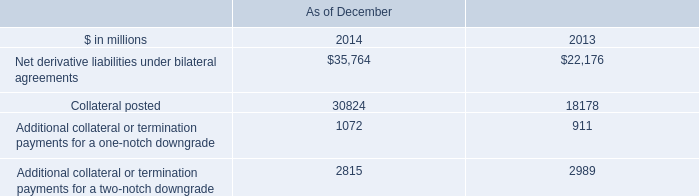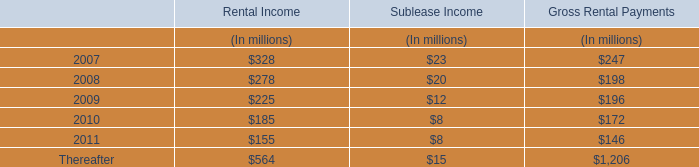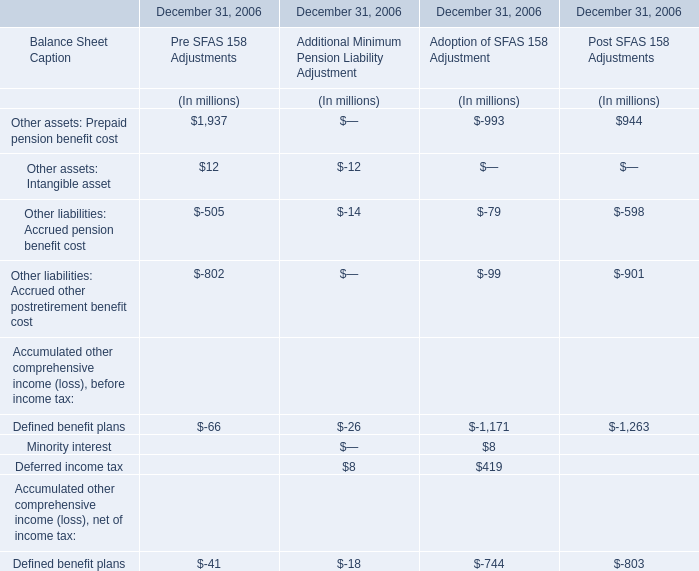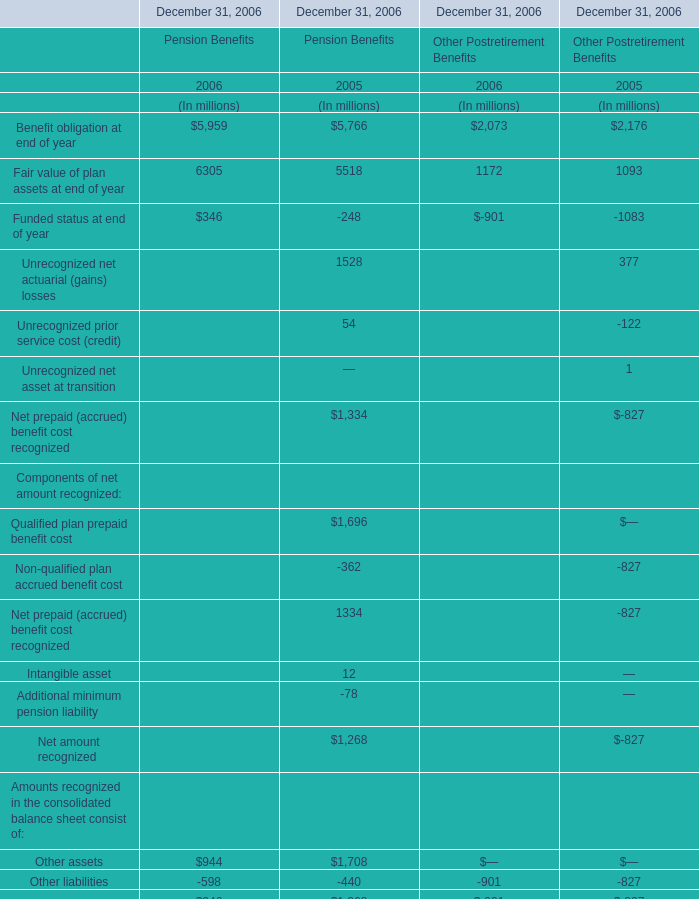What was the total amount of Fair value of plan assets at end of year in 2006 ? (in million) 
Computations: (6305 + 1172)
Answer: 7477.0. 